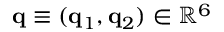Convert formula to latex. <formula><loc_0><loc_0><loc_500><loc_500>{ q } \equiv ( { q } _ { 1 } , { q } _ { 2 } ) \in \mathbb { R } ^ { 6 }</formula> 